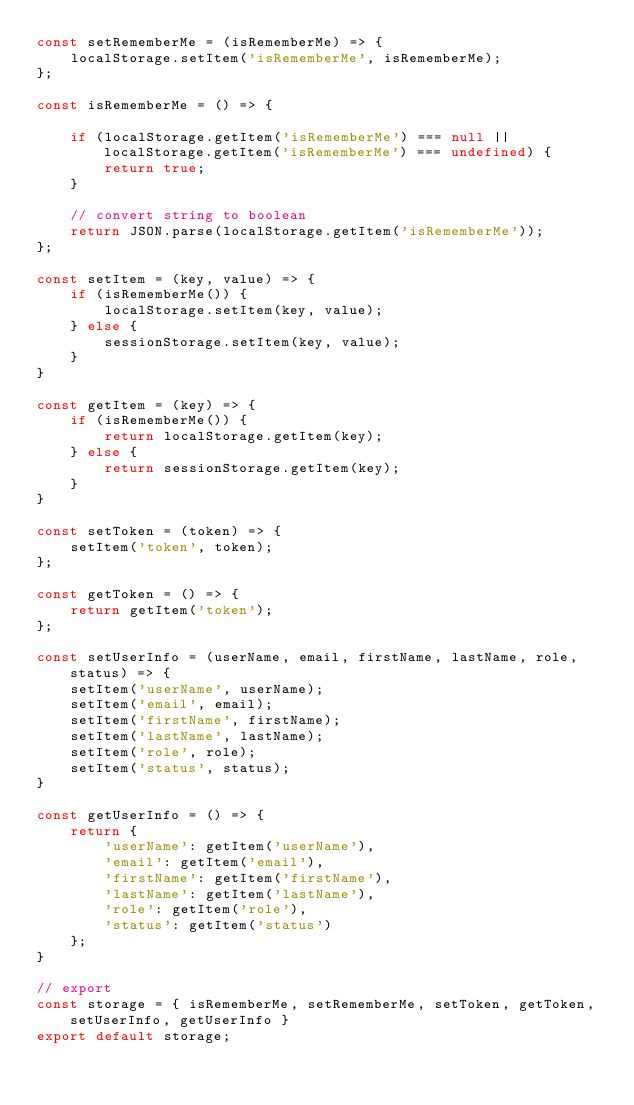<code> <loc_0><loc_0><loc_500><loc_500><_JavaScript_>const setRememberMe = (isRememberMe) => {
    localStorage.setItem('isRememberMe', isRememberMe);
};

const isRememberMe = () => {

    if (localStorage.getItem('isRememberMe') === null || localStorage.getItem('isRememberMe') === undefined) {
        return true;
    }

    // convert string to boolean
    return JSON.parse(localStorage.getItem('isRememberMe'));
};

const setItem = (key, value) => {
    if (isRememberMe()) {
        localStorage.setItem(key, value);
    } else {
        sessionStorage.setItem(key, value);
    }
}

const getItem = (key) => {
    if (isRememberMe()) {
        return localStorage.getItem(key);
    } else {
        return sessionStorage.getItem(key);
    }
}

const setToken = (token) => {
    setItem('token', token);
};

const getToken = () => {
    return getItem('token');
};

const setUserInfo = (userName, email, firstName, lastName, role, status) => {
    setItem('userName', userName);
    setItem('email', email);
    setItem('firstName', firstName);
    setItem('lastName', lastName);
    setItem('role', role);
    setItem('status', status);
}

const getUserInfo = () => {
    return {
        'userName': getItem('userName'),
        'email': getItem('email'),
        'firstName': getItem('firstName'),
        'lastName': getItem('lastName'),
        'role': getItem('role'),
        'status': getItem('status')
    };
}

// export
const storage = { isRememberMe, setRememberMe, setToken, getToken, setUserInfo, getUserInfo }
export default storage;</code> 